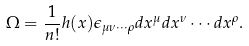Convert formula to latex. <formula><loc_0><loc_0><loc_500><loc_500>\Omega = \frac { 1 } { n ! } h ( x ) \epsilon _ { \mu \nu \cdots \rho } d x ^ { \mu } d x ^ { \nu } \cdots d x ^ { \rho } .</formula> 